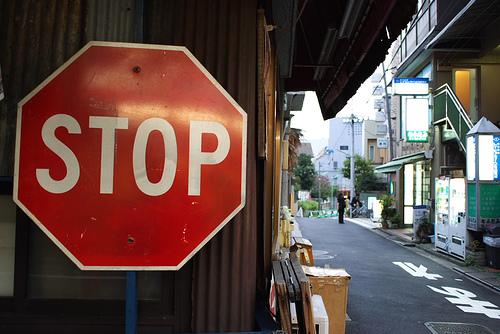Where is the stop sign?
Write a very short answer. Left. What is written on the street?
Write a very short answer. Stop. Is it raining?
Keep it brief. No. 